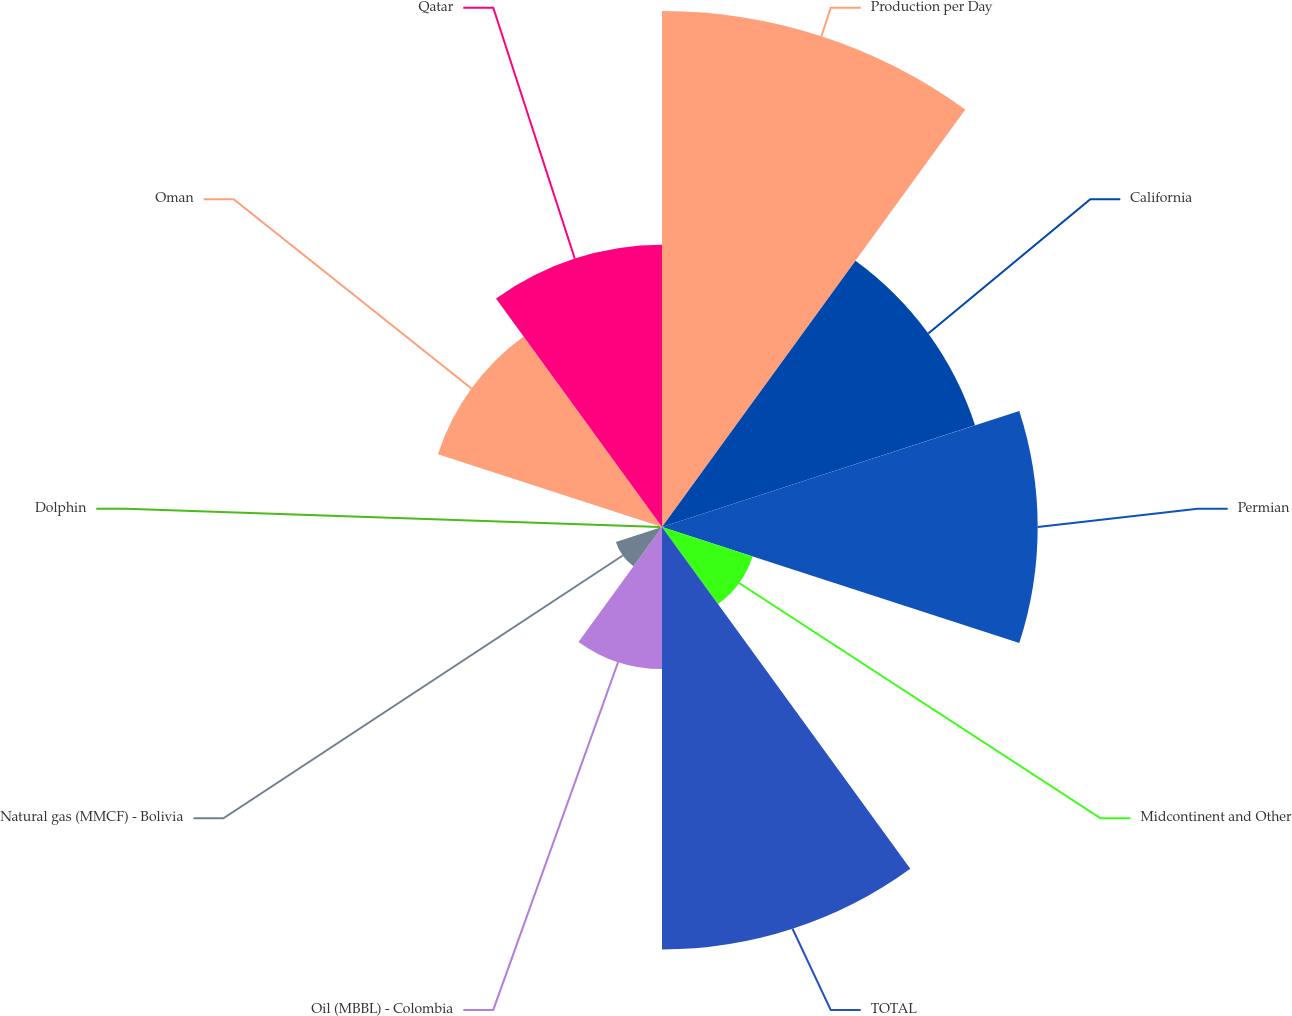Convert chart to OTSL. <chart><loc_0><loc_0><loc_500><loc_500><pie_chart><fcel>Production per Day<fcel>California<fcel>Permian<fcel>Midcontinent and Other<fcel>TOTAL<fcel>Oil (MBBL) - Colombia<fcel>Natural gas (MMCF) - Bolivia<fcel>Dolphin<fcel>Oman<fcel>Qatar<nl><fcel>21.07%<fcel>13.44%<fcel>15.34%<fcel>3.89%<fcel>17.25%<fcel>5.8%<fcel>1.98%<fcel>0.08%<fcel>9.62%<fcel>11.53%<nl></chart> 